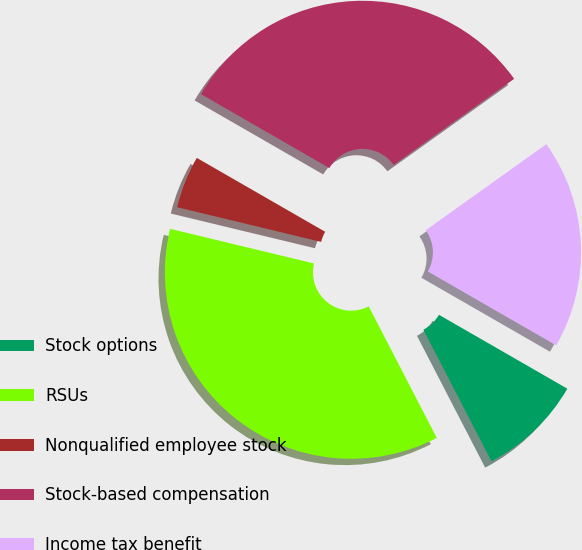Convert chart. <chart><loc_0><loc_0><loc_500><loc_500><pie_chart><fcel>Stock options<fcel>RSUs<fcel>Nonqualified employee stock<fcel>Stock-based compensation<fcel>Income tax benefit<nl><fcel>9.09%<fcel>36.36%<fcel>4.55%<fcel>31.82%<fcel>18.18%<nl></chart> 